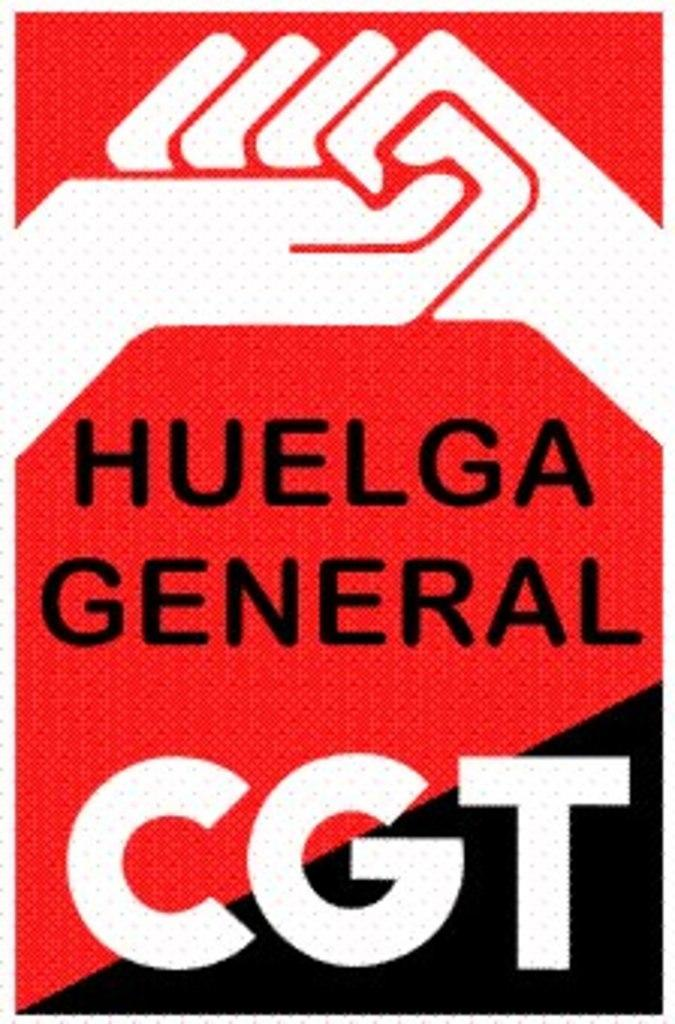<image>
Create a compact narrative representing the image presented. a poster for huelga general with red, white and black coloring. 